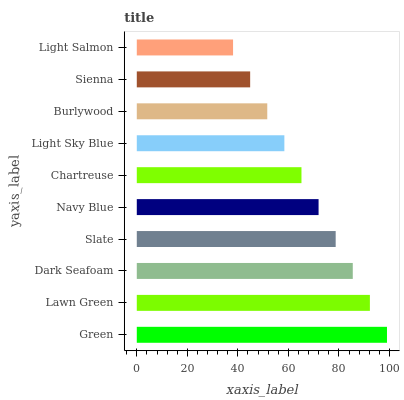Is Light Salmon the minimum?
Answer yes or no. Yes. Is Green the maximum?
Answer yes or no. Yes. Is Lawn Green the minimum?
Answer yes or no. No. Is Lawn Green the maximum?
Answer yes or no. No. Is Green greater than Lawn Green?
Answer yes or no. Yes. Is Lawn Green less than Green?
Answer yes or no. Yes. Is Lawn Green greater than Green?
Answer yes or no. No. Is Green less than Lawn Green?
Answer yes or no. No. Is Navy Blue the high median?
Answer yes or no. Yes. Is Chartreuse the low median?
Answer yes or no. Yes. Is Burlywood the high median?
Answer yes or no. No. Is Green the low median?
Answer yes or no. No. 